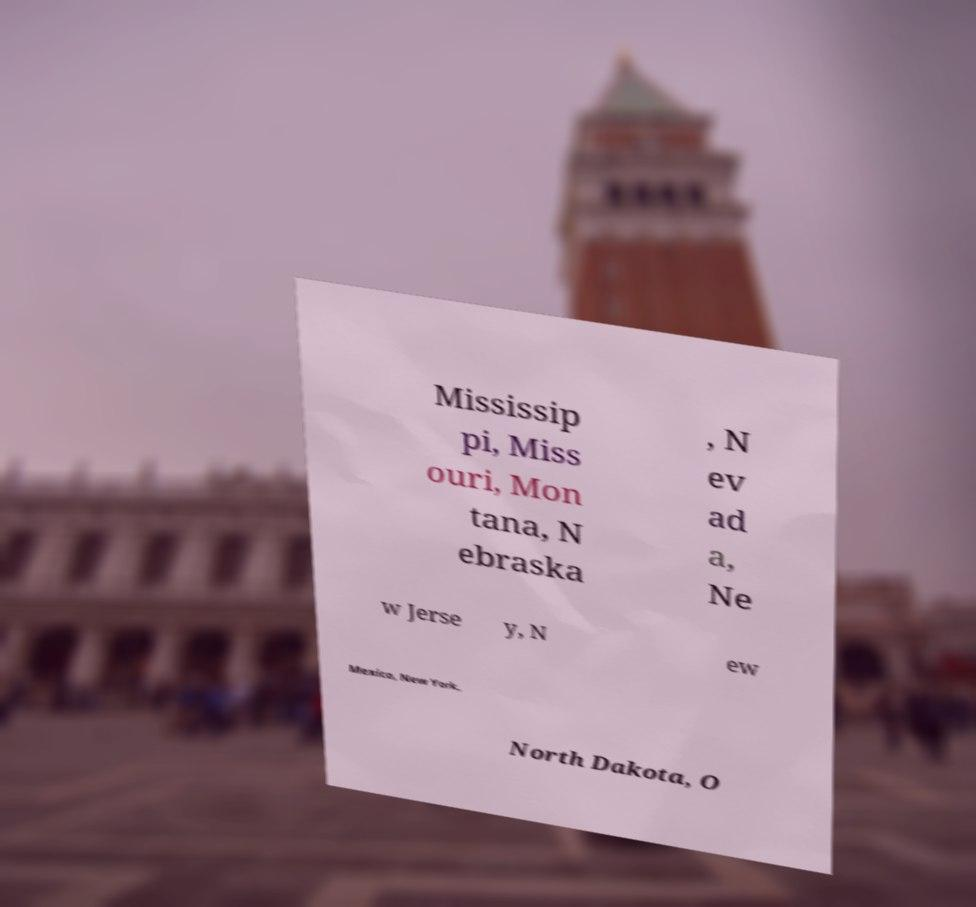Could you assist in decoding the text presented in this image and type it out clearly? Mississip pi, Miss ouri, Mon tana, N ebraska , N ev ad a, Ne w Jerse y, N ew Mexico, New York, North Dakota, O 